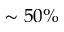<formula> <loc_0><loc_0><loc_500><loc_500>\sim 5 0 \%</formula> 